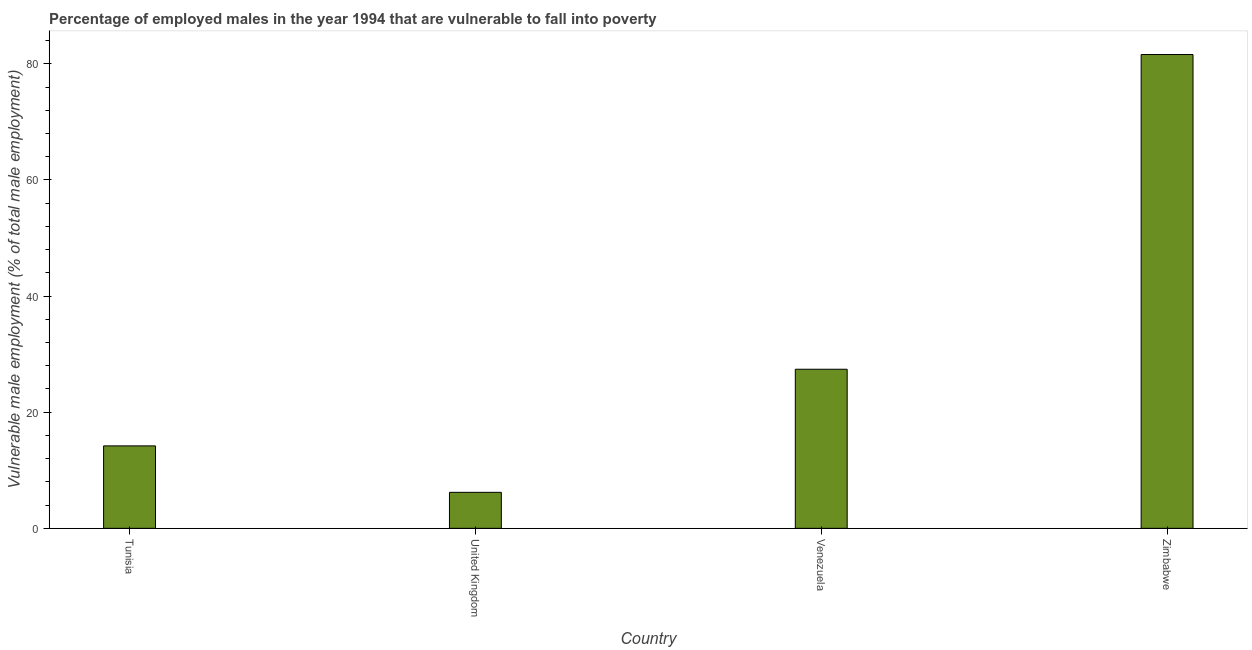Does the graph contain grids?
Your answer should be compact. No. What is the title of the graph?
Offer a very short reply. Percentage of employed males in the year 1994 that are vulnerable to fall into poverty. What is the label or title of the X-axis?
Keep it short and to the point. Country. What is the label or title of the Y-axis?
Offer a very short reply. Vulnerable male employment (% of total male employment). What is the percentage of employed males who are vulnerable to fall into poverty in Tunisia?
Your answer should be compact. 14.2. Across all countries, what is the maximum percentage of employed males who are vulnerable to fall into poverty?
Ensure brevity in your answer.  81.6. Across all countries, what is the minimum percentage of employed males who are vulnerable to fall into poverty?
Give a very brief answer. 6.2. In which country was the percentage of employed males who are vulnerable to fall into poverty maximum?
Provide a succinct answer. Zimbabwe. In which country was the percentage of employed males who are vulnerable to fall into poverty minimum?
Provide a succinct answer. United Kingdom. What is the sum of the percentage of employed males who are vulnerable to fall into poverty?
Make the answer very short. 129.4. What is the average percentage of employed males who are vulnerable to fall into poverty per country?
Ensure brevity in your answer.  32.35. What is the median percentage of employed males who are vulnerable to fall into poverty?
Offer a very short reply. 20.8. In how many countries, is the percentage of employed males who are vulnerable to fall into poverty greater than 76 %?
Give a very brief answer. 1. What is the ratio of the percentage of employed males who are vulnerable to fall into poverty in Tunisia to that in Venezuela?
Make the answer very short. 0.52. What is the difference between the highest and the second highest percentage of employed males who are vulnerable to fall into poverty?
Make the answer very short. 54.2. What is the difference between the highest and the lowest percentage of employed males who are vulnerable to fall into poverty?
Keep it short and to the point. 75.4. In how many countries, is the percentage of employed males who are vulnerable to fall into poverty greater than the average percentage of employed males who are vulnerable to fall into poverty taken over all countries?
Make the answer very short. 1. How many bars are there?
Provide a succinct answer. 4. Are all the bars in the graph horizontal?
Give a very brief answer. No. Are the values on the major ticks of Y-axis written in scientific E-notation?
Your response must be concise. No. What is the Vulnerable male employment (% of total male employment) in Tunisia?
Your answer should be compact. 14.2. What is the Vulnerable male employment (% of total male employment) in United Kingdom?
Keep it short and to the point. 6.2. What is the Vulnerable male employment (% of total male employment) in Venezuela?
Give a very brief answer. 27.4. What is the Vulnerable male employment (% of total male employment) in Zimbabwe?
Give a very brief answer. 81.6. What is the difference between the Vulnerable male employment (% of total male employment) in Tunisia and Venezuela?
Provide a short and direct response. -13.2. What is the difference between the Vulnerable male employment (% of total male employment) in Tunisia and Zimbabwe?
Provide a short and direct response. -67.4. What is the difference between the Vulnerable male employment (% of total male employment) in United Kingdom and Venezuela?
Provide a short and direct response. -21.2. What is the difference between the Vulnerable male employment (% of total male employment) in United Kingdom and Zimbabwe?
Give a very brief answer. -75.4. What is the difference between the Vulnerable male employment (% of total male employment) in Venezuela and Zimbabwe?
Provide a short and direct response. -54.2. What is the ratio of the Vulnerable male employment (% of total male employment) in Tunisia to that in United Kingdom?
Your answer should be compact. 2.29. What is the ratio of the Vulnerable male employment (% of total male employment) in Tunisia to that in Venezuela?
Make the answer very short. 0.52. What is the ratio of the Vulnerable male employment (% of total male employment) in Tunisia to that in Zimbabwe?
Provide a succinct answer. 0.17. What is the ratio of the Vulnerable male employment (% of total male employment) in United Kingdom to that in Venezuela?
Offer a very short reply. 0.23. What is the ratio of the Vulnerable male employment (% of total male employment) in United Kingdom to that in Zimbabwe?
Provide a succinct answer. 0.08. What is the ratio of the Vulnerable male employment (% of total male employment) in Venezuela to that in Zimbabwe?
Your answer should be very brief. 0.34. 